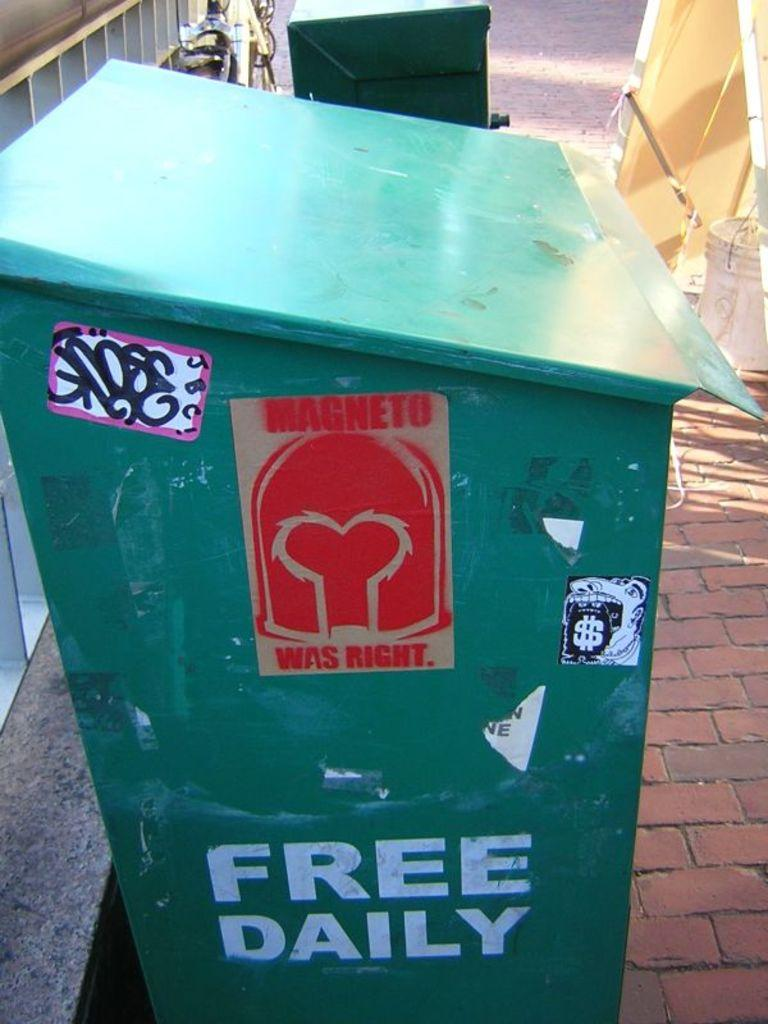<image>
Present a compact description of the photo's key features. Trash can with a red sticker and white words that say "Free Daily". 